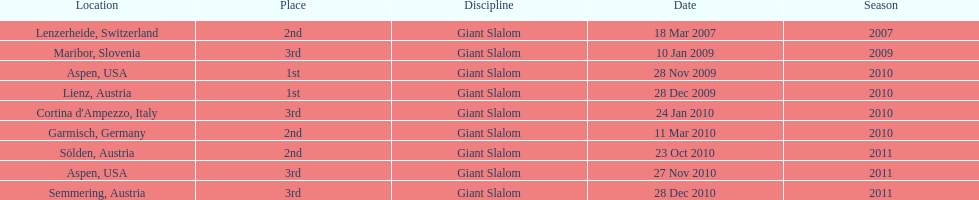What was the finishing place of the last race in december 2010? 3rd. 